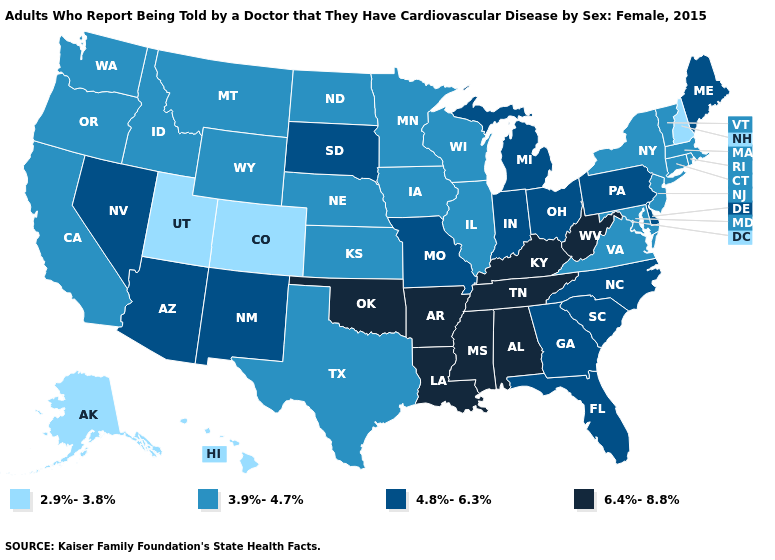Name the states that have a value in the range 4.8%-6.3%?
Give a very brief answer. Arizona, Delaware, Florida, Georgia, Indiana, Maine, Michigan, Missouri, Nevada, New Mexico, North Carolina, Ohio, Pennsylvania, South Carolina, South Dakota. Does Minnesota have a lower value than New Mexico?
Write a very short answer. Yes. Does Washington have a higher value than Wyoming?
Short answer required. No. Among the states that border Louisiana , does Mississippi have the lowest value?
Quick response, please. No. Does the first symbol in the legend represent the smallest category?
Keep it brief. Yes. Name the states that have a value in the range 2.9%-3.8%?
Quick response, please. Alaska, Colorado, Hawaii, New Hampshire, Utah. Which states have the lowest value in the USA?
Keep it brief. Alaska, Colorado, Hawaii, New Hampshire, Utah. What is the highest value in states that border Ohio?
Answer briefly. 6.4%-8.8%. What is the lowest value in states that border New Hampshire?
Keep it brief. 3.9%-4.7%. What is the value of South Dakota?
Keep it brief. 4.8%-6.3%. What is the value of Delaware?
Give a very brief answer. 4.8%-6.3%. Name the states that have a value in the range 2.9%-3.8%?
Give a very brief answer. Alaska, Colorado, Hawaii, New Hampshire, Utah. What is the value of California?
Write a very short answer. 3.9%-4.7%. What is the value of Kansas?
Write a very short answer. 3.9%-4.7%. Name the states that have a value in the range 4.8%-6.3%?
Short answer required. Arizona, Delaware, Florida, Georgia, Indiana, Maine, Michigan, Missouri, Nevada, New Mexico, North Carolina, Ohio, Pennsylvania, South Carolina, South Dakota. 